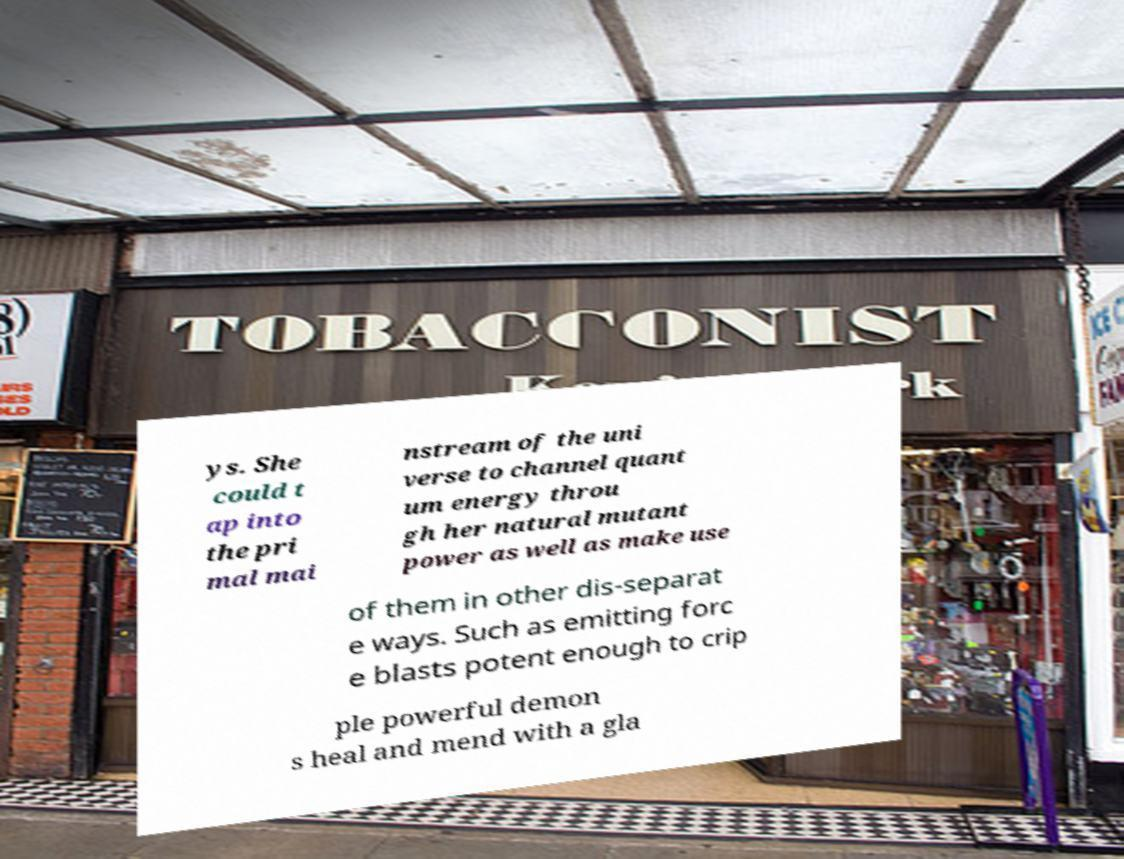For documentation purposes, I need the text within this image transcribed. Could you provide that? ys. She could t ap into the pri mal mai nstream of the uni verse to channel quant um energy throu gh her natural mutant power as well as make use of them in other dis-separat e ways. Such as emitting forc e blasts potent enough to crip ple powerful demon s heal and mend with a gla 